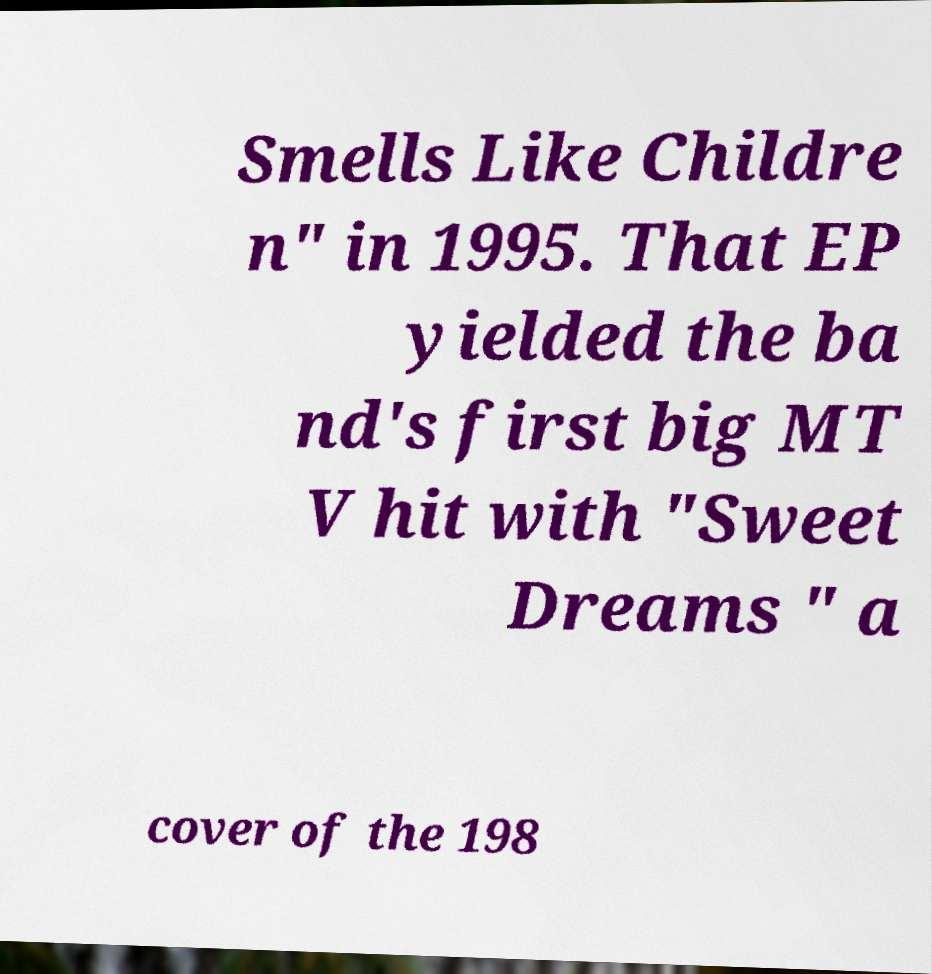Could you extract and type out the text from this image? Smells Like Childre n" in 1995. That EP yielded the ba nd's first big MT V hit with "Sweet Dreams " a cover of the 198 